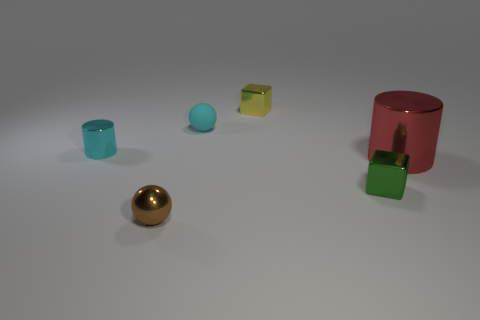There is a cylinder that is the same color as the small rubber object; what is it made of?
Offer a terse response. Metal. Does the tiny yellow block have the same material as the big object?
Make the answer very short. Yes. What number of small blocks have the same material as the green thing?
Provide a succinct answer. 1. What number of objects are either tiny balls that are in front of the matte ball or things that are in front of the cyan metal cylinder?
Your answer should be very brief. 3. Are there more metal balls right of the shiny ball than yellow shiny blocks on the right side of the red metallic thing?
Make the answer very short. No. What is the color of the small ball that is in front of the green metallic block?
Your answer should be very brief. Brown. Are there any large red metal objects that have the same shape as the cyan metal object?
Give a very brief answer. Yes. How many cyan objects are either cylinders or small shiny balls?
Offer a terse response. 1. Is there a shiny block that has the same size as the cyan sphere?
Provide a succinct answer. Yes. What number of green things are there?
Your answer should be very brief. 1. 